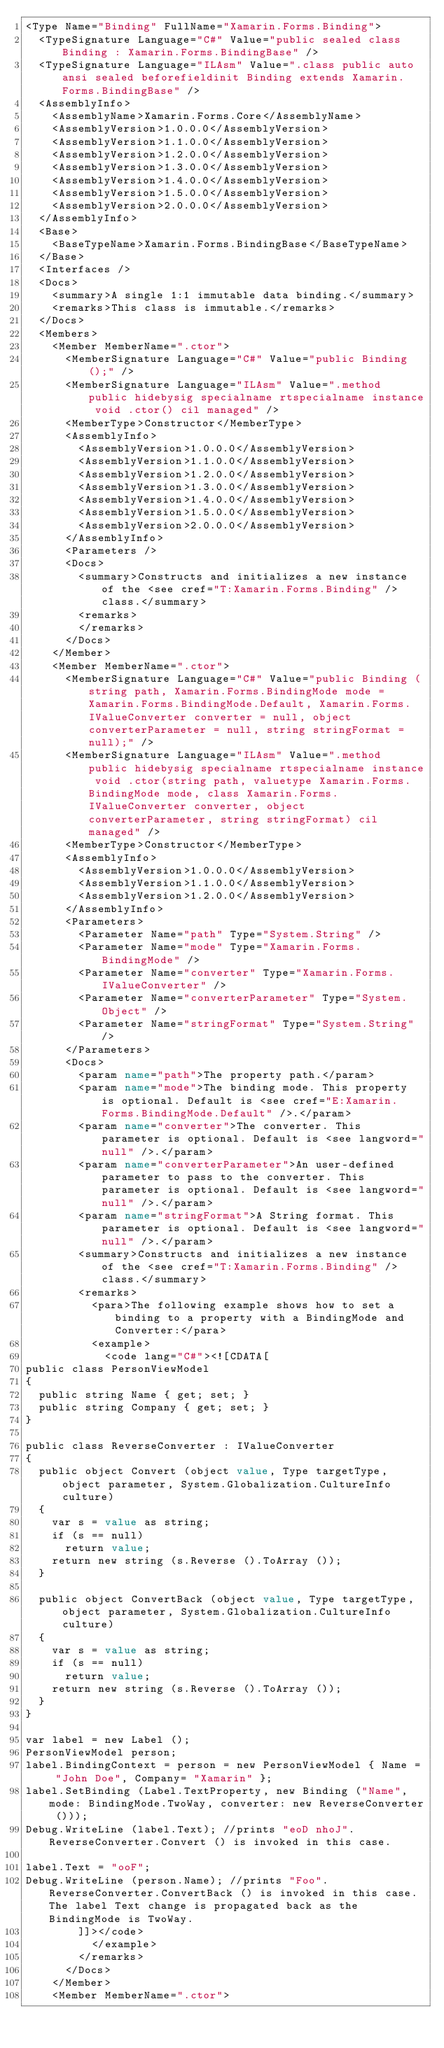Convert code to text. <code><loc_0><loc_0><loc_500><loc_500><_XML_><Type Name="Binding" FullName="Xamarin.Forms.Binding">
  <TypeSignature Language="C#" Value="public sealed class Binding : Xamarin.Forms.BindingBase" />
  <TypeSignature Language="ILAsm" Value=".class public auto ansi sealed beforefieldinit Binding extends Xamarin.Forms.BindingBase" />
  <AssemblyInfo>
    <AssemblyName>Xamarin.Forms.Core</AssemblyName>
    <AssemblyVersion>1.0.0.0</AssemblyVersion>
    <AssemblyVersion>1.1.0.0</AssemblyVersion>
    <AssemblyVersion>1.2.0.0</AssemblyVersion>
    <AssemblyVersion>1.3.0.0</AssemblyVersion>
    <AssemblyVersion>1.4.0.0</AssemblyVersion>
    <AssemblyVersion>1.5.0.0</AssemblyVersion>
    <AssemblyVersion>2.0.0.0</AssemblyVersion>
  </AssemblyInfo>
  <Base>
    <BaseTypeName>Xamarin.Forms.BindingBase</BaseTypeName>
  </Base>
  <Interfaces />
  <Docs>
    <summary>A single 1:1 immutable data binding.</summary>
    <remarks>This class is immutable.</remarks>
  </Docs>
  <Members>
    <Member MemberName=".ctor">
      <MemberSignature Language="C#" Value="public Binding ();" />
      <MemberSignature Language="ILAsm" Value=".method public hidebysig specialname rtspecialname instance void .ctor() cil managed" />
      <MemberType>Constructor</MemberType>
      <AssemblyInfo>
        <AssemblyVersion>1.0.0.0</AssemblyVersion>
        <AssemblyVersion>1.1.0.0</AssemblyVersion>
        <AssemblyVersion>1.2.0.0</AssemblyVersion>
        <AssemblyVersion>1.3.0.0</AssemblyVersion>
        <AssemblyVersion>1.4.0.0</AssemblyVersion>
        <AssemblyVersion>1.5.0.0</AssemblyVersion>
        <AssemblyVersion>2.0.0.0</AssemblyVersion>
      </AssemblyInfo>
      <Parameters />
      <Docs>
        <summary>Constructs and initializes a new instance of the <see cref="T:Xamarin.Forms.Binding" /> class.</summary>
        <remarks>
        </remarks>
      </Docs>
    </Member>
    <Member MemberName=".ctor">
      <MemberSignature Language="C#" Value="public Binding (string path, Xamarin.Forms.BindingMode mode = Xamarin.Forms.BindingMode.Default, Xamarin.Forms.IValueConverter converter = null, object converterParameter = null, string stringFormat = null);" />
      <MemberSignature Language="ILAsm" Value=".method public hidebysig specialname rtspecialname instance void .ctor(string path, valuetype Xamarin.Forms.BindingMode mode, class Xamarin.Forms.IValueConverter converter, object converterParameter, string stringFormat) cil managed" />
      <MemberType>Constructor</MemberType>
      <AssemblyInfo>
        <AssemblyVersion>1.0.0.0</AssemblyVersion>
        <AssemblyVersion>1.1.0.0</AssemblyVersion>
        <AssemblyVersion>1.2.0.0</AssemblyVersion>
      </AssemblyInfo>
      <Parameters>
        <Parameter Name="path" Type="System.String" />
        <Parameter Name="mode" Type="Xamarin.Forms.BindingMode" />
        <Parameter Name="converter" Type="Xamarin.Forms.IValueConverter" />
        <Parameter Name="converterParameter" Type="System.Object" />
        <Parameter Name="stringFormat" Type="System.String" />
      </Parameters>
      <Docs>
        <param name="path">The property path.</param>
        <param name="mode">The binding mode. This property is optional. Default is <see cref="E:Xamarin.Forms.BindingMode.Default" />.</param>
        <param name="converter">The converter. This parameter is optional. Default is <see langword="null" />.</param>
        <param name="converterParameter">An user-defined parameter to pass to the converter. This parameter is optional. Default is <see langword="null" />.</param>
        <param name="stringFormat">A String format. This parameter is optional. Default is <see langword="null" />.</param>
        <summary>Constructs and initializes a new instance of the <see cref="T:Xamarin.Forms.Binding" /> class.</summary>
        <remarks>
          <para>The following example shows how to set a binding to a property with a BindingMode and Converter:</para>
          <example>
            <code lang="C#"><![CDATA[
public class PersonViewModel
{
  public string Name { get; set; }
  public string Company { get; set; }
}

public class ReverseConverter : IValueConverter
{
  public object Convert (object value, Type targetType, object parameter, System.Globalization.CultureInfo culture)
  {
    var s = value as string;
    if (s == null)
      return value;
    return new string (s.Reverse ().ToArray ());
  }

  public object ConvertBack (object value, Type targetType, object parameter, System.Globalization.CultureInfo culture)
  {
    var s = value as string;
    if (s == null)
      return value;
    return new string (s.Reverse ().ToArray ());
  }
}

var label = new Label ();
PersonViewModel person;
label.BindingContext = person = new PersonViewModel { Name = "John Doe", Company= "Xamarin" };
label.SetBinding (Label.TextProperty, new Binding ("Name", mode: BindingMode.TwoWay, converter: new ReverseConverter ()));
Debug.WriteLine (label.Text); //prints "eoD nhoJ". ReverseConverter.Convert () is invoked in this case.

label.Text = "ooF";
Debug.WriteLine (person.Name); //prints "Foo". ReverseConverter.ConvertBack () is invoked in this case. The label Text change is propagated back as the BindingMode is TwoWay.
        ]]></code>
          </example>
        </remarks>
      </Docs>
    </Member>
    <Member MemberName=".ctor"></code> 